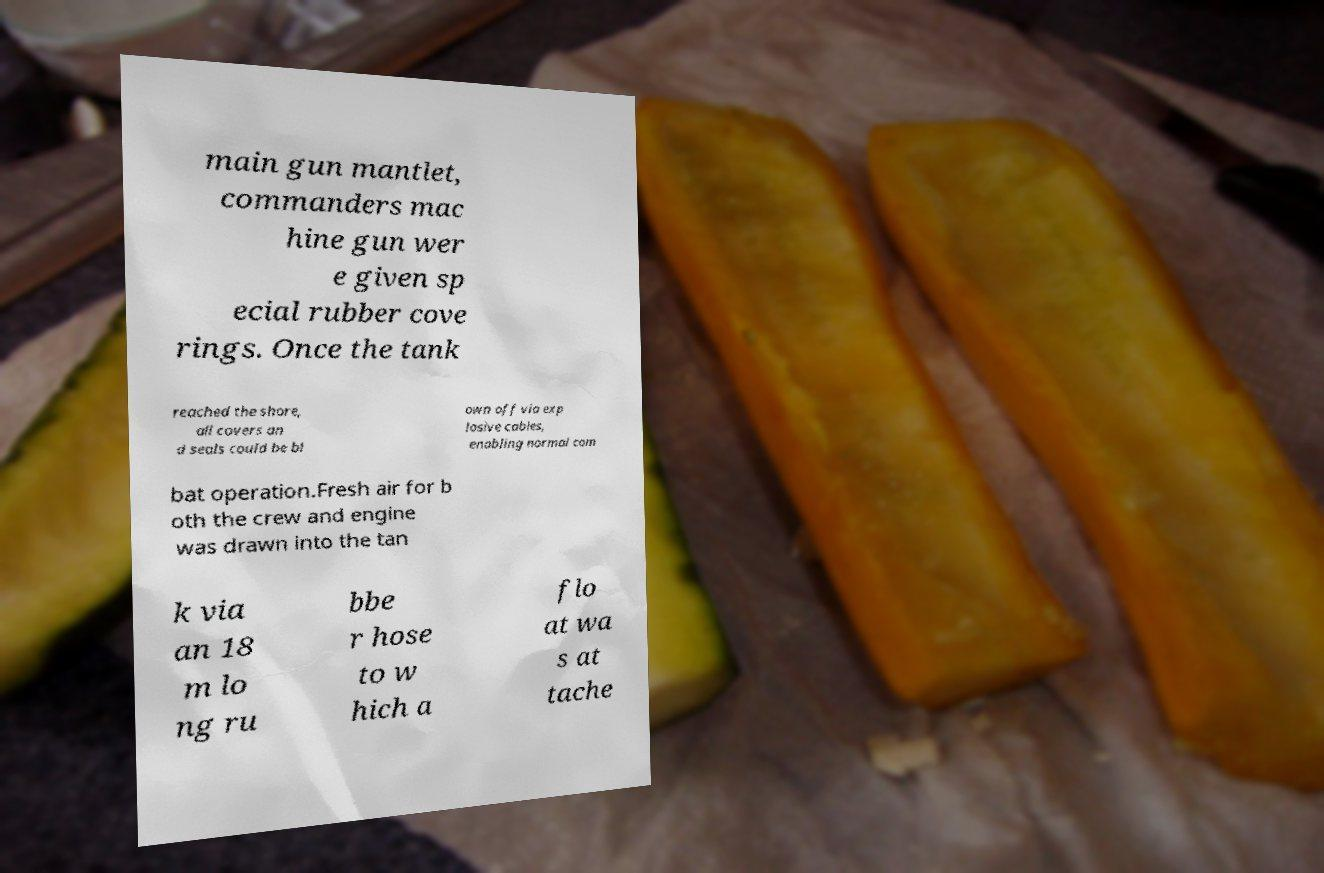There's text embedded in this image that I need extracted. Can you transcribe it verbatim? main gun mantlet, commanders mac hine gun wer e given sp ecial rubber cove rings. Once the tank reached the shore, all covers an d seals could be bl own off via exp losive cables, enabling normal com bat operation.Fresh air for b oth the crew and engine was drawn into the tan k via an 18 m lo ng ru bbe r hose to w hich a flo at wa s at tache 